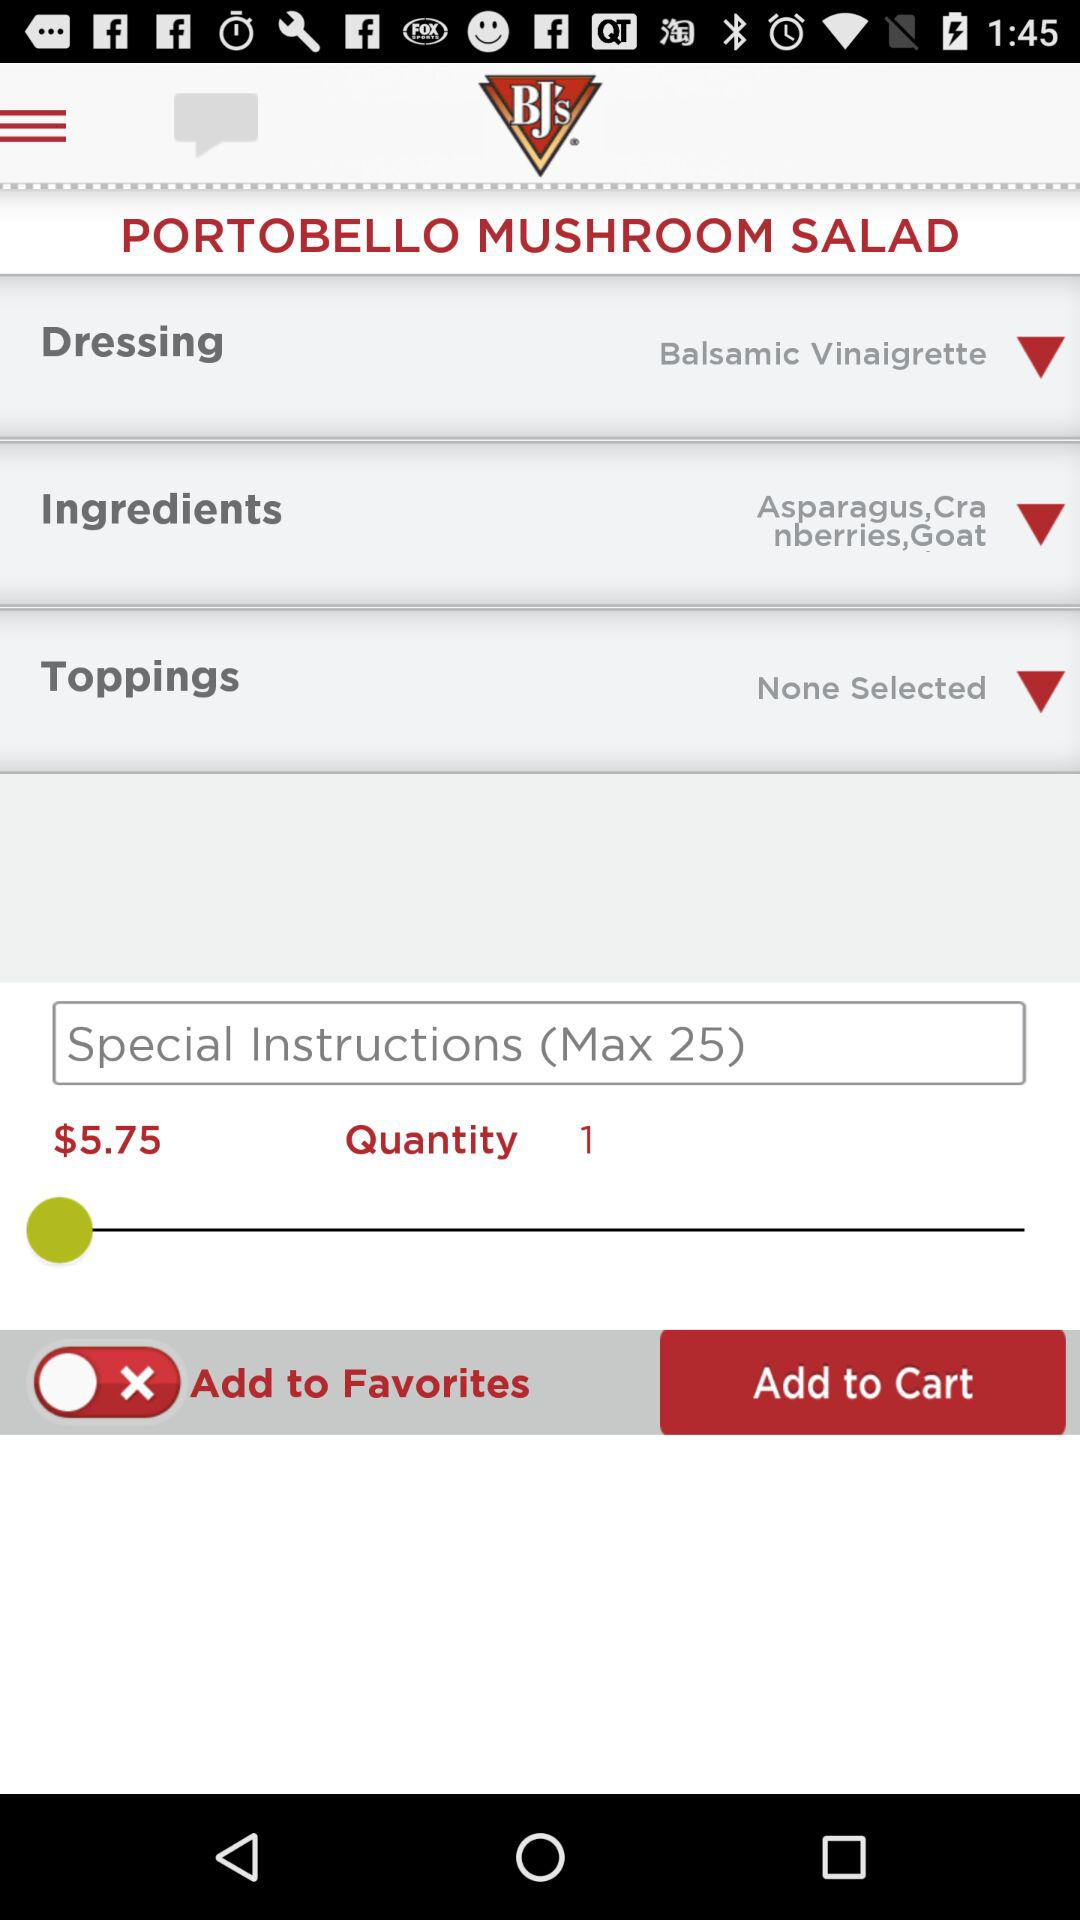What are the ingredients used in the salad? The ingredients used in the salad are asparagus, cranberries and goat. 